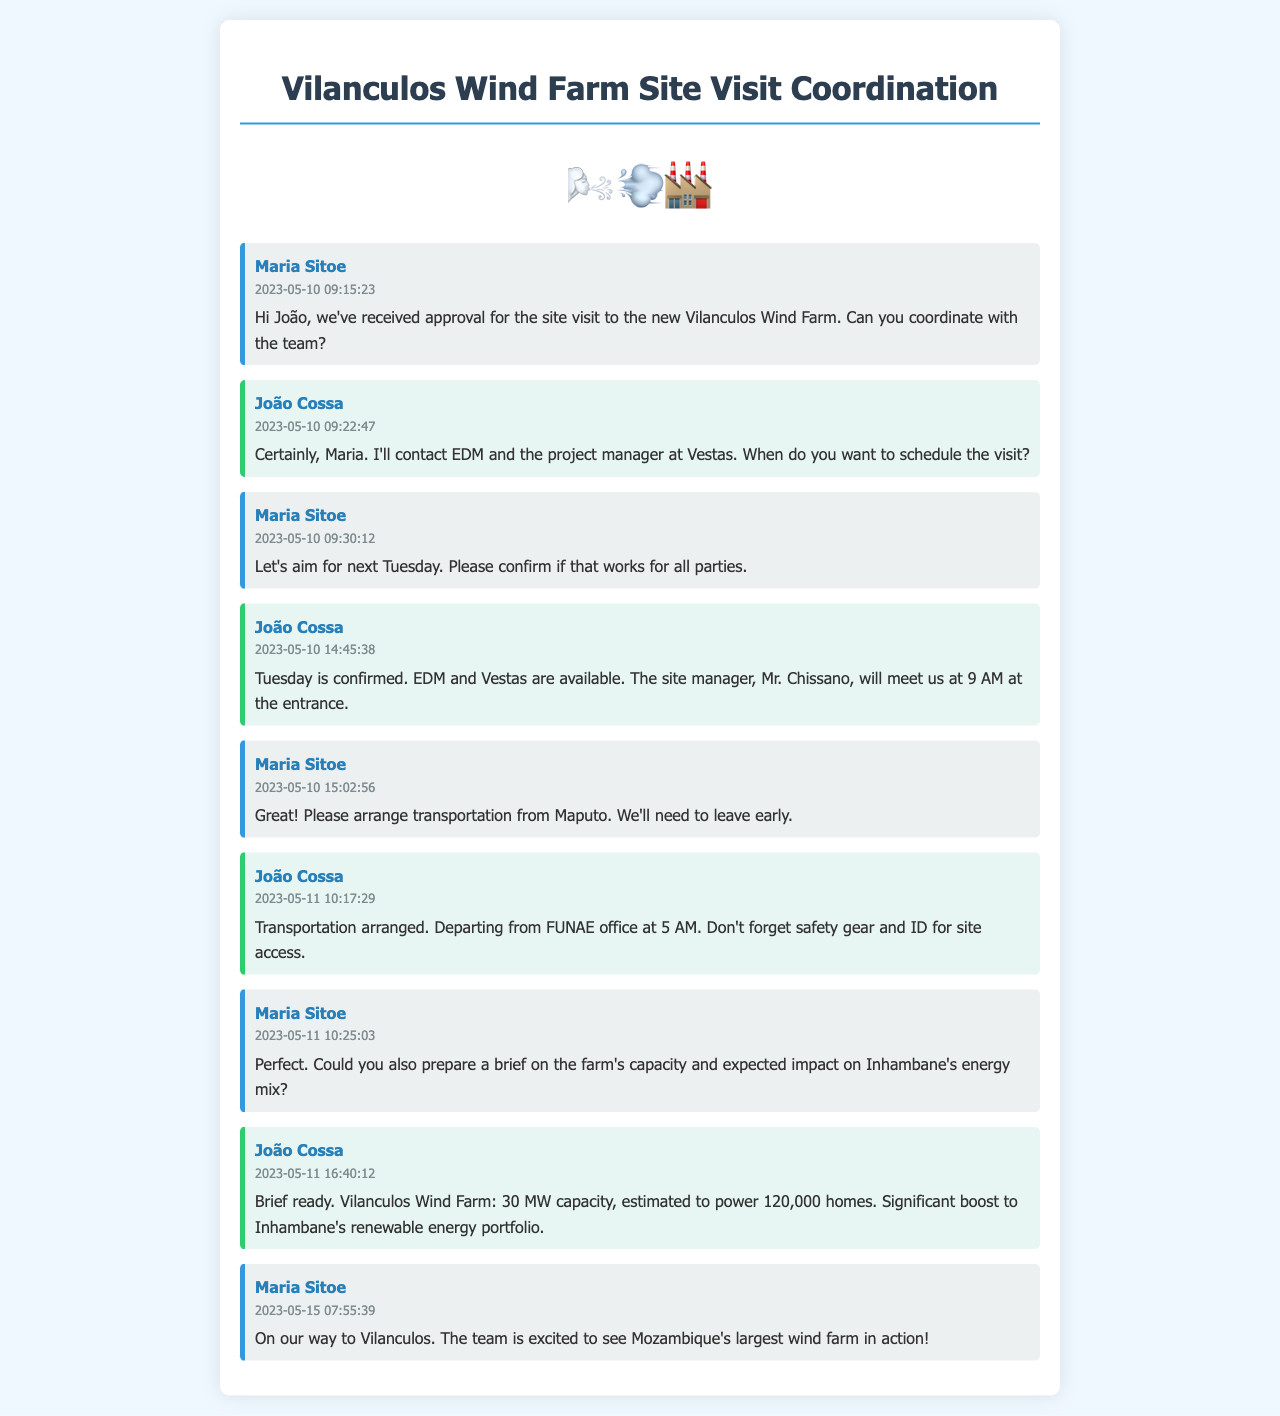What is the date of the site visit? The site visit is scheduled for next Tuesday after the conversation on May 10, which makes it May 16, 2023.
Answer: May 16, 2023 Who is the site manager meeting the team? The site manager's name is mentioned in João's confirmation message about the site visit.
Answer: Mr. Chissano What time will the team meet at the site? The meeting time is stated clearly in João's response about the site access.
Answer: 9 AM What is the capacity of the Vilanculos Wind Farm? The capacity is listed in João's brief regarding the farm’s details.
Answer: 30 MW How many homes is the wind farm estimated to power? The number of homes the wind farm is estimated to power is mentioned in the same brief.
Answer: 120,000 What does Maria request for the site visit preparation? Maria requests a brief on the farm’s capacity and expected impact before the visit.
Answer: A brief on capacity and impact At what time will the transportation depart from Maputo? The departure time for the arranged transportation is mentioned in João's message regarding transport.
Answer: 5 AM What is the main subject of the text messages? The subject revolves around coordinating a site visit to a specific energy project.
Answer: Vilanculos Wind Farm Site Visit 